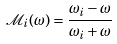Convert formula to latex. <formula><loc_0><loc_0><loc_500><loc_500>\mathcal { M } _ { i } ( \omega ) = \frac { \omega _ { i } - \omega } { \omega _ { i } + \omega }</formula> 